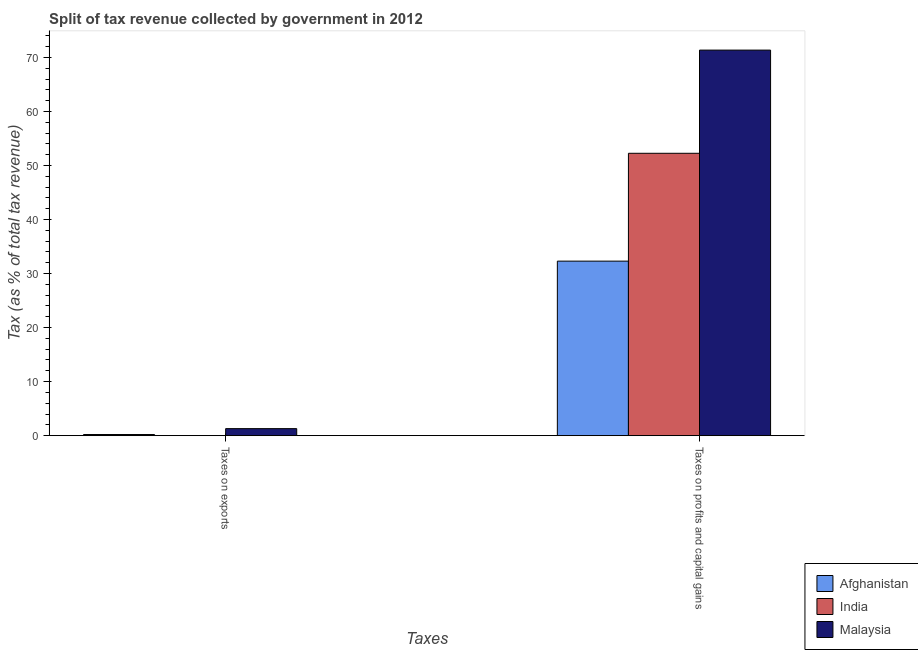How many different coloured bars are there?
Make the answer very short. 3. How many groups of bars are there?
Ensure brevity in your answer.  2. Are the number of bars per tick equal to the number of legend labels?
Provide a short and direct response. Yes. How many bars are there on the 2nd tick from the left?
Your answer should be very brief. 3. What is the label of the 1st group of bars from the left?
Give a very brief answer. Taxes on exports. What is the percentage of revenue obtained from taxes on profits and capital gains in India?
Make the answer very short. 52.25. Across all countries, what is the maximum percentage of revenue obtained from taxes on profits and capital gains?
Offer a terse response. 71.35. Across all countries, what is the minimum percentage of revenue obtained from taxes on profits and capital gains?
Ensure brevity in your answer.  32.3. In which country was the percentage of revenue obtained from taxes on profits and capital gains maximum?
Give a very brief answer. Malaysia. In which country was the percentage of revenue obtained from taxes on exports minimum?
Offer a very short reply. India. What is the total percentage of revenue obtained from taxes on exports in the graph?
Your response must be concise. 1.51. What is the difference between the percentage of revenue obtained from taxes on exports in Afghanistan and that in Malaysia?
Your answer should be compact. -1.09. What is the difference between the percentage of revenue obtained from taxes on exports in India and the percentage of revenue obtained from taxes on profits and capital gains in Afghanistan?
Give a very brief answer. -32.29. What is the average percentage of revenue obtained from taxes on exports per country?
Provide a short and direct response. 0.5. What is the difference between the percentage of revenue obtained from taxes on profits and capital gains and percentage of revenue obtained from taxes on exports in Malaysia?
Give a very brief answer. 70.05. In how many countries, is the percentage of revenue obtained from taxes on exports greater than 26 %?
Make the answer very short. 0. What is the ratio of the percentage of revenue obtained from taxes on exports in Malaysia to that in India?
Your answer should be very brief. 199.79. What does the 1st bar from the left in Taxes on profits and capital gains represents?
Provide a succinct answer. Afghanistan. What does the 1st bar from the right in Taxes on exports represents?
Make the answer very short. Malaysia. How many bars are there?
Your answer should be very brief. 6. Does the graph contain any zero values?
Your response must be concise. No. Where does the legend appear in the graph?
Your response must be concise. Bottom right. How many legend labels are there?
Ensure brevity in your answer.  3. How are the legend labels stacked?
Make the answer very short. Vertical. What is the title of the graph?
Provide a short and direct response. Split of tax revenue collected by government in 2012. What is the label or title of the X-axis?
Ensure brevity in your answer.  Taxes. What is the label or title of the Y-axis?
Make the answer very short. Tax (as % of total tax revenue). What is the Tax (as % of total tax revenue) of Afghanistan in Taxes on exports?
Keep it short and to the point. 0.21. What is the Tax (as % of total tax revenue) in India in Taxes on exports?
Your answer should be compact. 0.01. What is the Tax (as % of total tax revenue) of Malaysia in Taxes on exports?
Give a very brief answer. 1.3. What is the Tax (as % of total tax revenue) of Afghanistan in Taxes on profits and capital gains?
Make the answer very short. 32.3. What is the Tax (as % of total tax revenue) of India in Taxes on profits and capital gains?
Your answer should be compact. 52.25. What is the Tax (as % of total tax revenue) of Malaysia in Taxes on profits and capital gains?
Your answer should be compact. 71.35. Across all Taxes, what is the maximum Tax (as % of total tax revenue) in Afghanistan?
Make the answer very short. 32.3. Across all Taxes, what is the maximum Tax (as % of total tax revenue) in India?
Make the answer very short. 52.25. Across all Taxes, what is the maximum Tax (as % of total tax revenue) in Malaysia?
Offer a very short reply. 71.35. Across all Taxes, what is the minimum Tax (as % of total tax revenue) in Afghanistan?
Ensure brevity in your answer.  0.21. Across all Taxes, what is the minimum Tax (as % of total tax revenue) in India?
Your answer should be very brief. 0.01. Across all Taxes, what is the minimum Tax (as % of total tax revenue) of Malaysia?
Keep it short and to the point. 1.3. What is the total Tax (as % of total tax revenue) of Afghanistan in the graph?
Your answer should be compact. 32.5. What is the total Tax (as % of total tax revenue) of India in the graph?
Your answer should be very brief. 52.26. What is the total Tax (as % of total tax revenue) of Malaysia in the graph?
Keep it short and to the point. 72.65. What is the difference between the Tax (as % of total tax revenue) in Afghanistan in Taxes on exports and that in Taxes on profits and capital gains?
Your answer should be compact. -32.09. What is the difference between the Tax (as % of total tax revenue) of India in Taxes on exports and that in Taxes on profits and capital gains?
Give a very brief answer. -52.25. What is the difference between the Tax (as % of total tax revenue) of Malaysia in Taxes on exports and that in Taxes on profits and capital gains?
Make the answer very short. -70.05. What is the difference between the Tax (as % of total tax revenue) in Afghanistan in Taxes on exports and the Tax (as % of total tax revenue) in India in Taxes on profits and capital gains?
Ensure brevity in your answer.  -52.05. What is the difference between the Tax (as % of total tax revenue) of Afghanistan in Taxes on exports and the Tax (as % of total tax revenue) of Malaysia in Taxes on profits and capital gains?
Offer a terse response. -71.14. What is the difference between the Tax (as % of total tax revenue) in India in Taxes on exports and the Tax (as % of total tax revenue) in Malaysia in Taxes on profits and capital gains?
Provide a succinct answer. -71.34. What is the average Tax (as % of total tax revenue) in Afghanistan per Taxes?
Offer a very short reply. 16.25. What is the average Tax (as % of total tax revenue) in India per Taxes?
Your answer should be very brief. 26.13. What is the average Tax (as % of total tax revenue) of Malaysia per Taxes?
Ensure brevity in your answer.  36.32. What is the difference between the Tax (as % of total tax revenue) in Afghanistan and Tax (as % of total tax revenue) in India in Taxes on exports?
Your response must be concise. 0.2. What is the difference between the Tax (as % of total tax revenue) of Afghanistan and Tax (as % of total tax revenue) of Malaysia in Taxes on exports?
Offer a terse response. -1.09. What is the difference between the Tax (as % of total tax revenue) in India and Tax (as % of total tax revenue) in Malaysia in Taxes on exports?
Provide a short and direct response. -1.29. What is the difference between the Tax (as % of total tax revenue) in Afghanistan and Tax (as % of total tax revenue) in India in Taxes on profits and capital gains?
Your answer should be compact. -19.96. What is the difference between the Tax (as % of total tax revenue) in Afghanistan and Tax (as % of total tax revenue) in Malaysia in Taxes on profits and capital gains?
Ensure brevity in your answer.  -39.05. What is the difference between the Tax (as % of total tax revenue) of India and Tax (as % of total tax revenue) of Malaysia in Taxes on profits and capital gains?
Make the answer very short. -19.1. What is the ratio of the Tax (as % of total tax revenue) in Afghanistan in Taxes on exports to that in Taxes on profits and capital gains?
Offer a very short reply. 0.01. What is the ratio of the Tax (as % of total tax revenue) of India in Taxes on exports to that in Taxes on profits and capital gains?
Ensure brevity in your answer.  0. What is the ratio of the Tax (as % of total tax revenue) in Malaysia in Taxes on exports to that in Taxes on profits and capital gains?
Your answer should be compact. 0.02. What is the difference between the highest and the second highest Tax (as % of total tax revenue) in Afghanistan?
Your answer should be compact. 32.09. What is the difference between the highest and the second highest Tax (as % of total tax revenue) of India?
Give a very brief answer. 52.25. What is the difference between the highest and the second highest Tax (as % of total tax revenue) of Malaysia?
Provide a succinct answer. 70.05. What is the difference between the highest and the lowest Tax (as % of total tax revenue) in Afghanistan?
Your answer should be compact. 32.09. What is the difference between the highest and the lowest Tax (as % of total tax revenue) of India?
Offer a very short reply. 52.25. What is the difference between the highest and the lowest Tax (as % of total tax revenue) of Malaysia?
Ensure brevity in your answer.  70.05. 